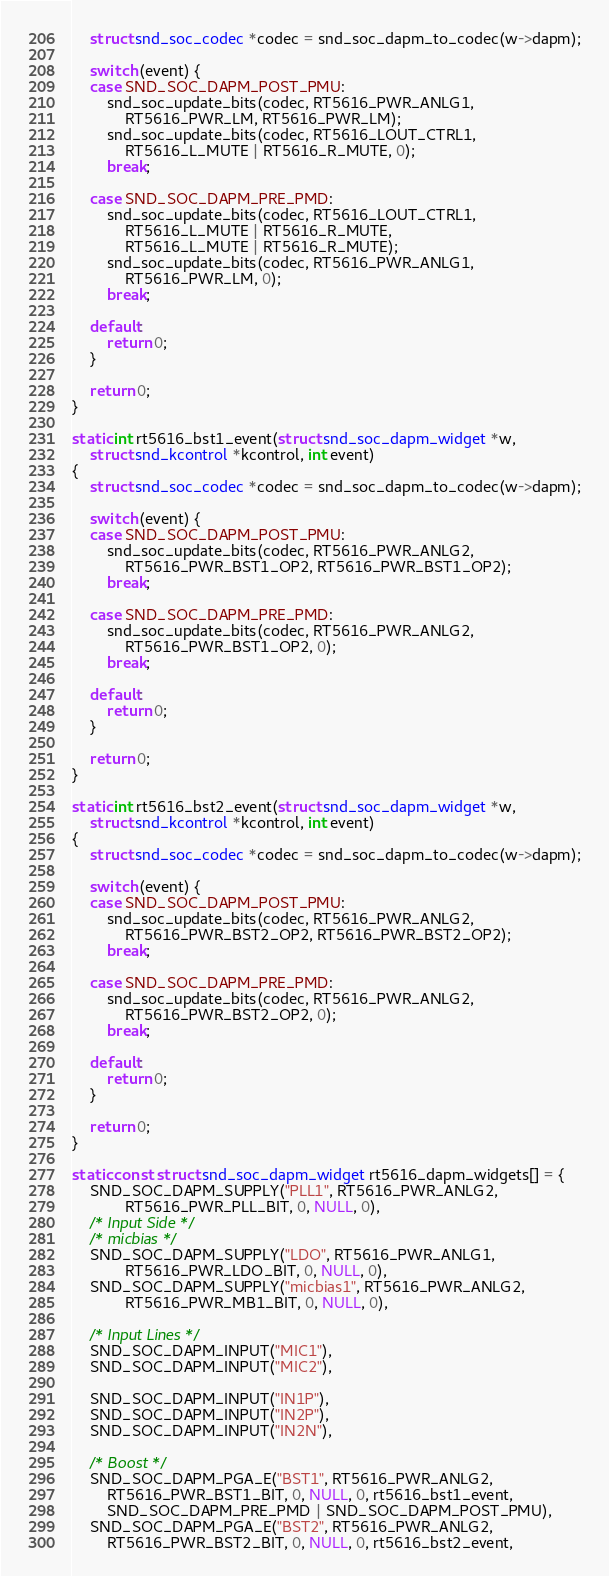Convert code to text. <code><loc_0><loc_0><loc_500><loc_500><_C_>	struct snd_soc_codec *codec = snd_soc_dapm_to_codec(w->dapm);

	switch (event) {
	case SND_SOC_DAPM_POST_PMU:
		snd_soc_update_bits(codec, RT5616_PWR_ANLG1,
			RT5616_PWR_LM, RT5616_PWR_LM);
		snd_soc_update_bits(codec, RT5616_LOUT_CTRL1,
			RT5616_L_MUTE | RT5616_R_MUTE, 0);
		break;

	case SND_SOC_DAPM_PRE_PMD:
		snd_soc_update_bits(codec, RT5616_LOUT_CTRL1,
			RT5616_L_MUTE | RT5616_R_MUTE,
			RT5616_L_MUTE | RT5616_R_MUTE);
		snd_soc_update_bits(codec, RT5616_PWR_ANLG1,
			RT5616_PWR_LM, 0);
		break;

	default:
		return 0;
	}

	return 0;
}

static int rt5616_bst1_event(struct snd_soc_dapm_widget *w,
	struct snd_kcontrol *kcontrol, int event)
{
	struct snd_soc_codec *codec = snd_soc_dapm_to_codec(w->dapm);

	switch (event) {
	case SND_SOC_DAPM_POST_PMU:
		snd_soc_update_bits(codec, RT5616_PWR_ANLG2,
			RT5616_PWR_BST1_OP2, RT5616_PWR_BST1_OP2);
		break;

	case SND_SOC_DAPM_PRE_PMD:
		snd_soc_update_bits(codec, RT5616_PWR_ANLG2,
			RT5616_PWR_BST1_OP2, 0);
		break;

	default:
		return 0;
	}

	return 0;
}

static int rt5616_bst2_event(struct snd_soc_dapm_widget *w,
	struct snd_kcontrol *kcontrol, int event)
{
	struct snd_soc_codec *codec = snd_soc_dapm_to_codec(w->dapm);

	switch (event) {
	case SND_SOC_DAPM_POST_PMU:
		snd_soc_update_bits(codec, RT5616_PWR_ANLG2,
			RT5616_PWR_BST2_OP2, RT5616_PWR_BST2_OP2);
		break;

	case SND_SOC_DAPM_PRE_PMD:
		snd_soc_update_bits(codec, RT5616_PWR_ANLG2,
			RT5616_PWR_BST2_OP2, 0);
		break;

	default:
		return 0;
	}

	return 0;
}

static const struct snd_soc_dapm_widget rt5616_dapm_widgets[] = {
	SND_SOC_DAPM_SUPPLY("PLL1", RT5616_PWR_ANLG2,
			RT5616_PWR_PLL_BIT, 0, NULL, 0),
	/* Input Side */
	/* micbias */
	SND_SOC_DAPM_SUPPLY("LDO", RT5616_PWR_ANLG1,
			RT5616_PWR_LDO_BIT, 0, NULL, 0),
	SND_SOC_DAPM_SUPPLY("micbias1", RT5616_PWR_ANLG2,
			RT5616_PWR_MB1_BIT, 0, NULL, 0),

	/* Input Lines */
	SND_SOC_DAPM_INPUT("MIC1"),
	SND_SOC_DAPM_INPUT("MIC2"),

	SND_SOC_DAPM_INPUT("IN1P"),
	SND_SOC_DAPM_INPUT("IN2P"),
	SND_SOC_DAPM_INPUT("IN2N"),

	/* Boost */
	SND_SOC_DAPM_PGA_E("BST1", RT5616_PWR_ANLG2,
		RT5616_PWR_BST1_BIT, 0, NULL, 0, rt5616_bst1_event,
		SND_SOC_DAPM_PRE_PMD | SND_SOC_DAPM_POST_PMU),
	SND_SOC_DAPM_PGA_E("BST2", RT5616_PWR_ANLG2,
		RT5616_PWR_BST2_BIT, 0, NULL, 0, rt5616_bst2_event,</code> 